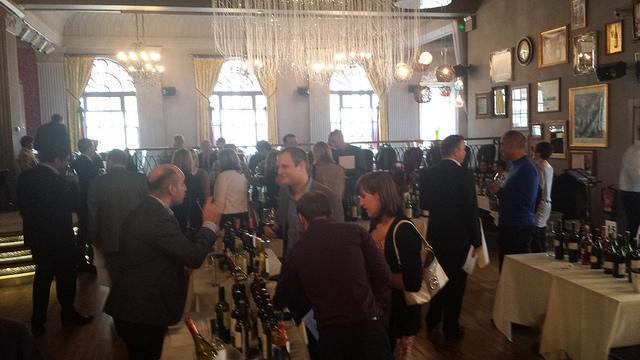New Orleans is inventor of what?
Indicate the correct choice and explain in the format: 'Answer: answer
Rationale: rationale.'
Options: Beverages, soft drinks, coffee, cocktail. Answer: cocktail.
Rationale: This type of drink was invented in the french quarter's carousel bar. 